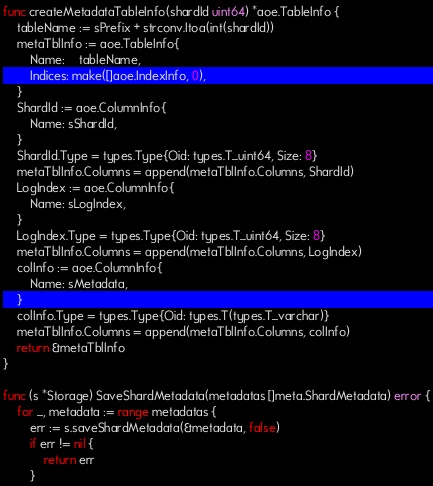Convert code to text. <code><loc_0><loc_0><loc_500><loc_500><_Go_>func createMetadataTableInfo(shardId uint64) *aoe.TableInfo {
	tableName := sPrefix + strconv.Itoa(int(shardId))
	metaTblInfo := aoe.TableInfo{
		Name:    tableName,
		Indices: make([]aoe.IndexInfo, 0),
	}
	ShardId := aoe.ColumnInfo{
		Name: sShardId,
	}
	ShardId.Type = types.Type{Oid: types.T_uint64, Size: 8}
	metaTblInfo.Columns = append(metaTblInfo.Columns, ShardId)
	LogIndex := aoe.ColumnInfo{
		Name: sLogIndex,
	}
	LogIndex.Type = types.Type{Oid: types.T_uint64, Size: 8}
	metaTblInfo.Columns = append(metaTblInfo.Columns, LogIndex)
	colInfo := aoe.ColumnInfo{
		Name: sMetadata,
	}
	colInfo.Type = types.Type{Oid: types.T(types.T_varchar)}
	metaTblInfo.Columns = append(metaTblInfo.Columns, colInfo)
	return &metaTblInfo
}

func (s *Storage) SaveShardMetadata(metadatas []meta.ShardMetadata) error {
	for _, metadata := range metadatas {
		err := s.saveShardMetadata(&metadata, false)
		if err != nil {
			return err
		}</code> 